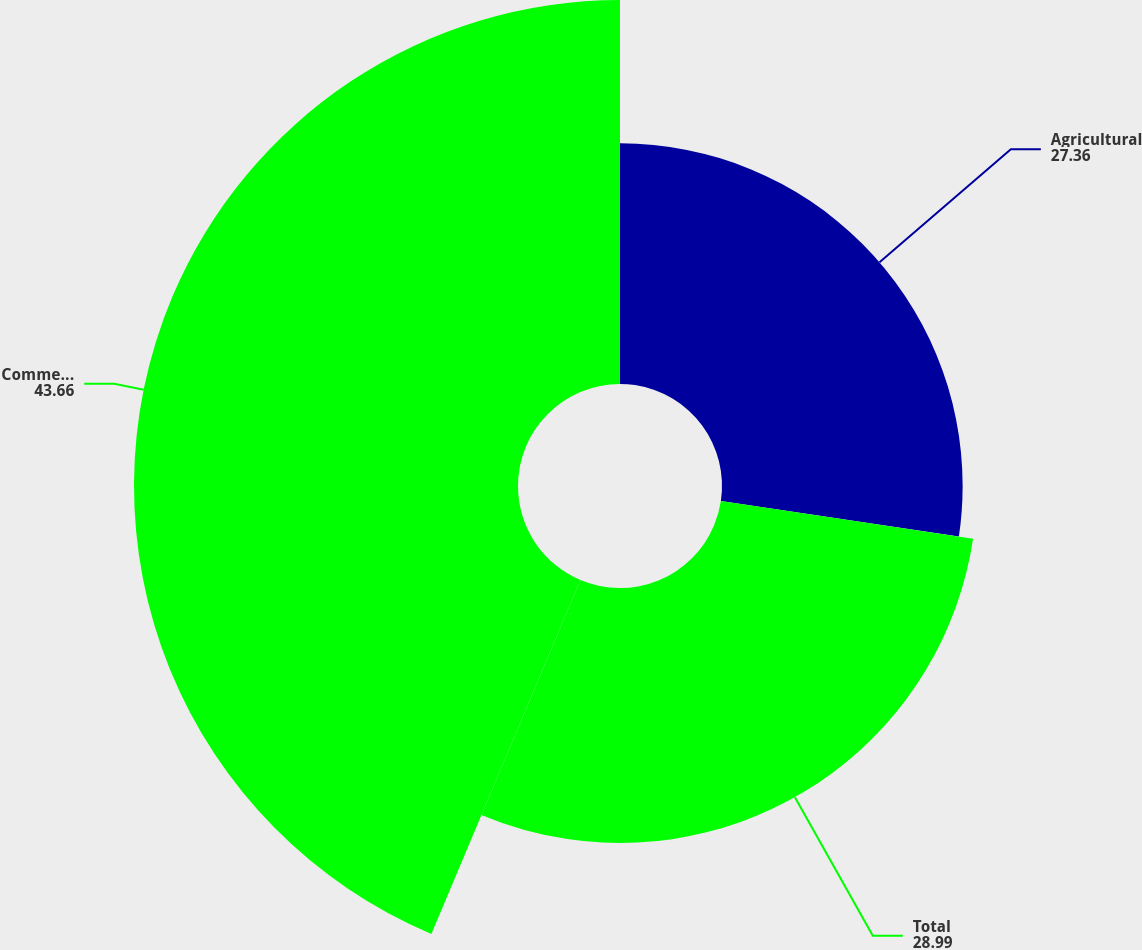Convert chart. <chart><loc_0><loc_0><loc_500><loc_500><pie_chart><fcel>Agricultural<fcel>Total<fcel>Commercial<nl><fcel>27.36%<fcel>28.99%<fcel>43.66%<nl></chart> 